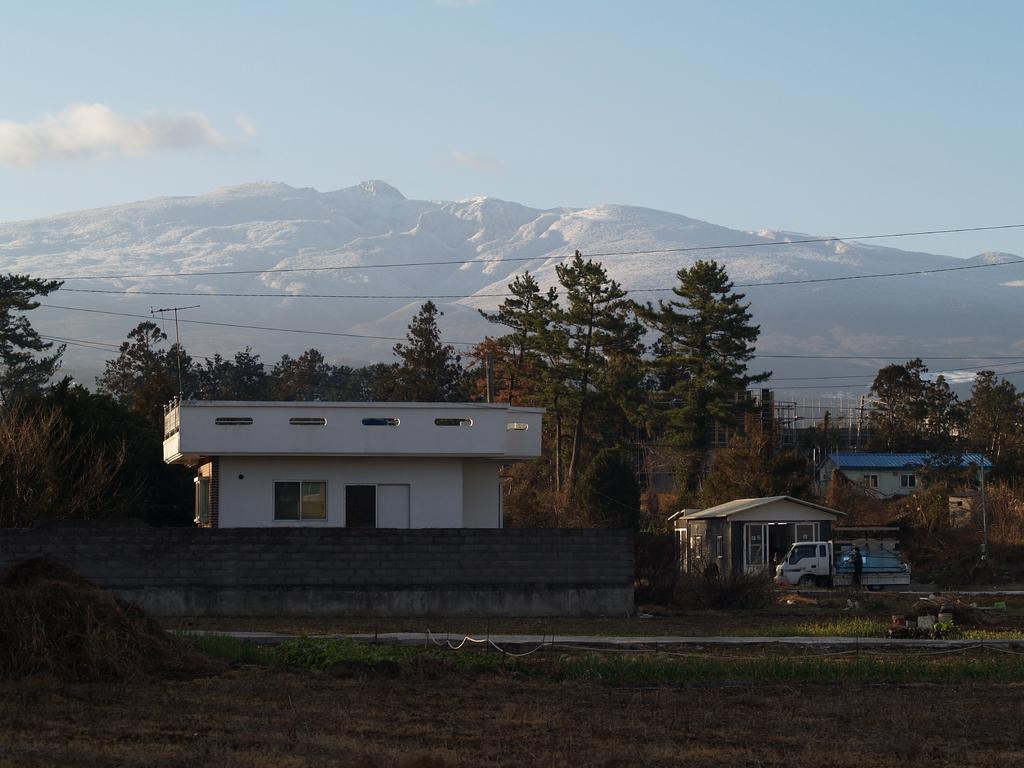Please provide a concise description of this image. In this image, we can see houses, trees, poles along with wires and we can see a vehicle and a person on the road and there are hills. At the top, there are clouds in the sky and at the bottom, there is ground. 